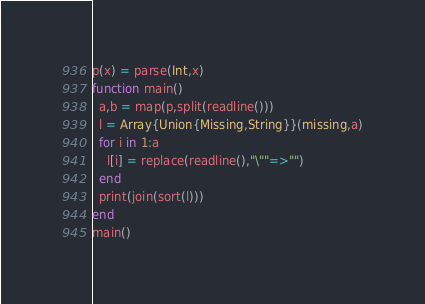<code> <loc_0><loc_0><loc_500><loc_500><_Julia_>p(x) = parse(Int,x)
function main()
  a,b = map(p,split(readline()))
  l = Array{Union{Missing,String}}(missing,a)
  for i in 1:a
    l[i] = replace(readline(),"\""=>"")
  end
  print(join(sort(l)))
end
main()</code> 